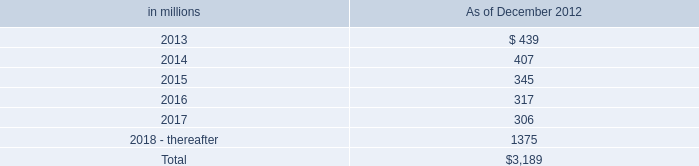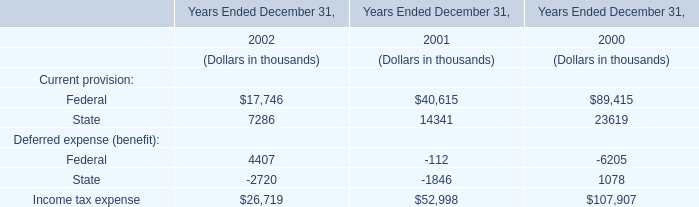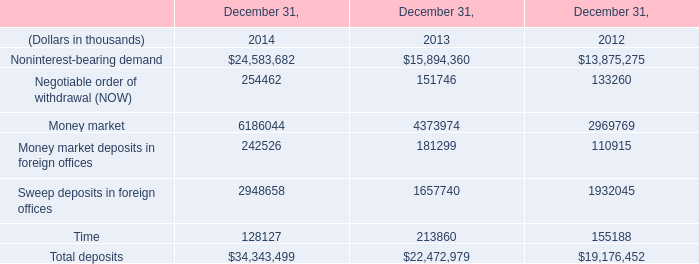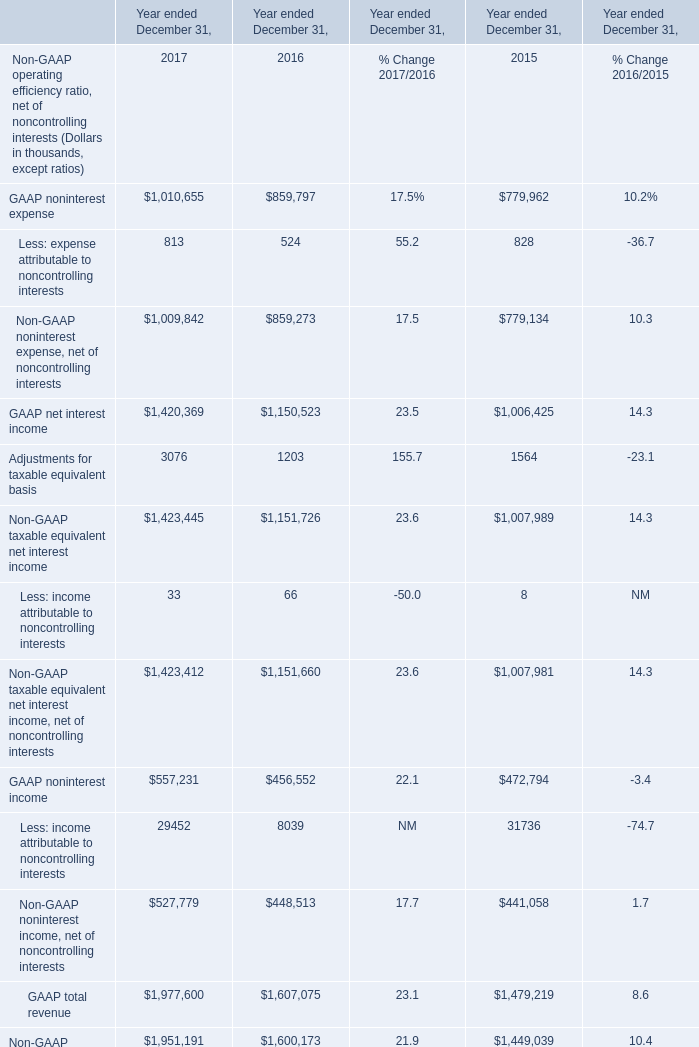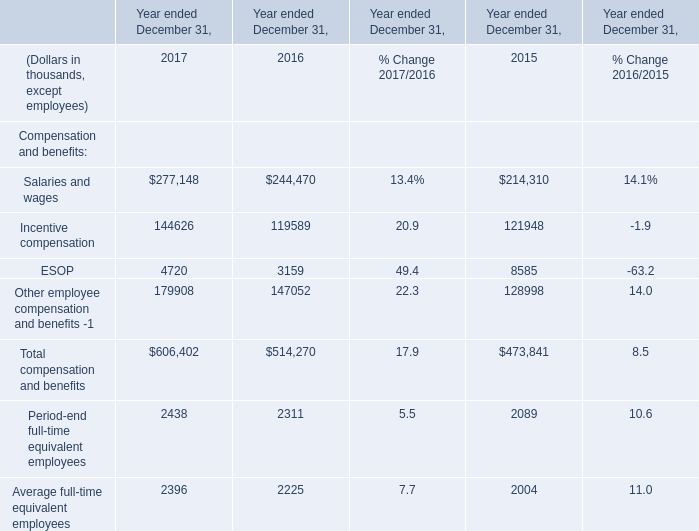Does the value of GAAP net interest income in 2017 greater than that in 2016? 
Answer: NO. 